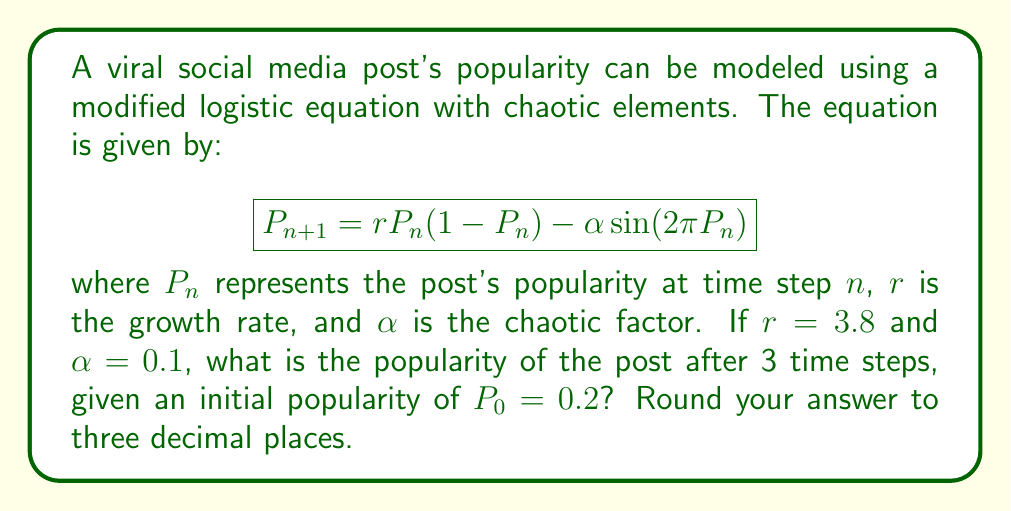What is the answer to this math problem? To solve this problem, we need to iterate the given equation for three time steps:

Step 1: Calculate $P_1$
$$\begin{align}
P_1 &= rP_0(1-P_0) - \alpha \sin(2\pi P_0) \\
&= 3.8 \cdot 0.2(1-0.2) - 0.1 \sin(2\pi \cdot 0.2) \\
&= 3.8 \cdot 0.2 \cdot 0.8 - 0.1 \sin(0.4\pi) \\
&= 0.608 - 0.1 \cdot 0.951 \\
&= 0.513
\end{align}$$

Step 2: Calculate $P_2$
$$\begin{align}
P_2 &= rP_1(1-P_1) - \alpha \sin(2\pi P_1) \\
&= 3.8 \cdot 0.513(1-0.513) - 0.1 \sin(2\pi \cdot 0.513) \\
&= 3.8 \cdot 0.513 \cdot 0.487 - 0.1 \sin(1.026\pi) \\
&= 0.949 - 0.1 \cdot 0.081 \\
&= 0.941
\end{align}$$

Step 3: Calculate $P_3$
$$\begin{align}
P_3 &= rP_2(1-P_2) - \alpha \sin(2\pi P_2) \\
&= 3.8 \cdot 0.941(1-0.941) - 0.1 \sin(2\pi \cdot 0.941) \\
&= 3.8 \cdot 0.941 \cdot 0.059 - 0.1 \sin(1.882\pi) \\
&= 0.211 - 0.1 \cdot 0.372 \\
&= 0.174
\end{align}$$

Rounding to three decimal places, we get 0.174.
Answer: 0.174 